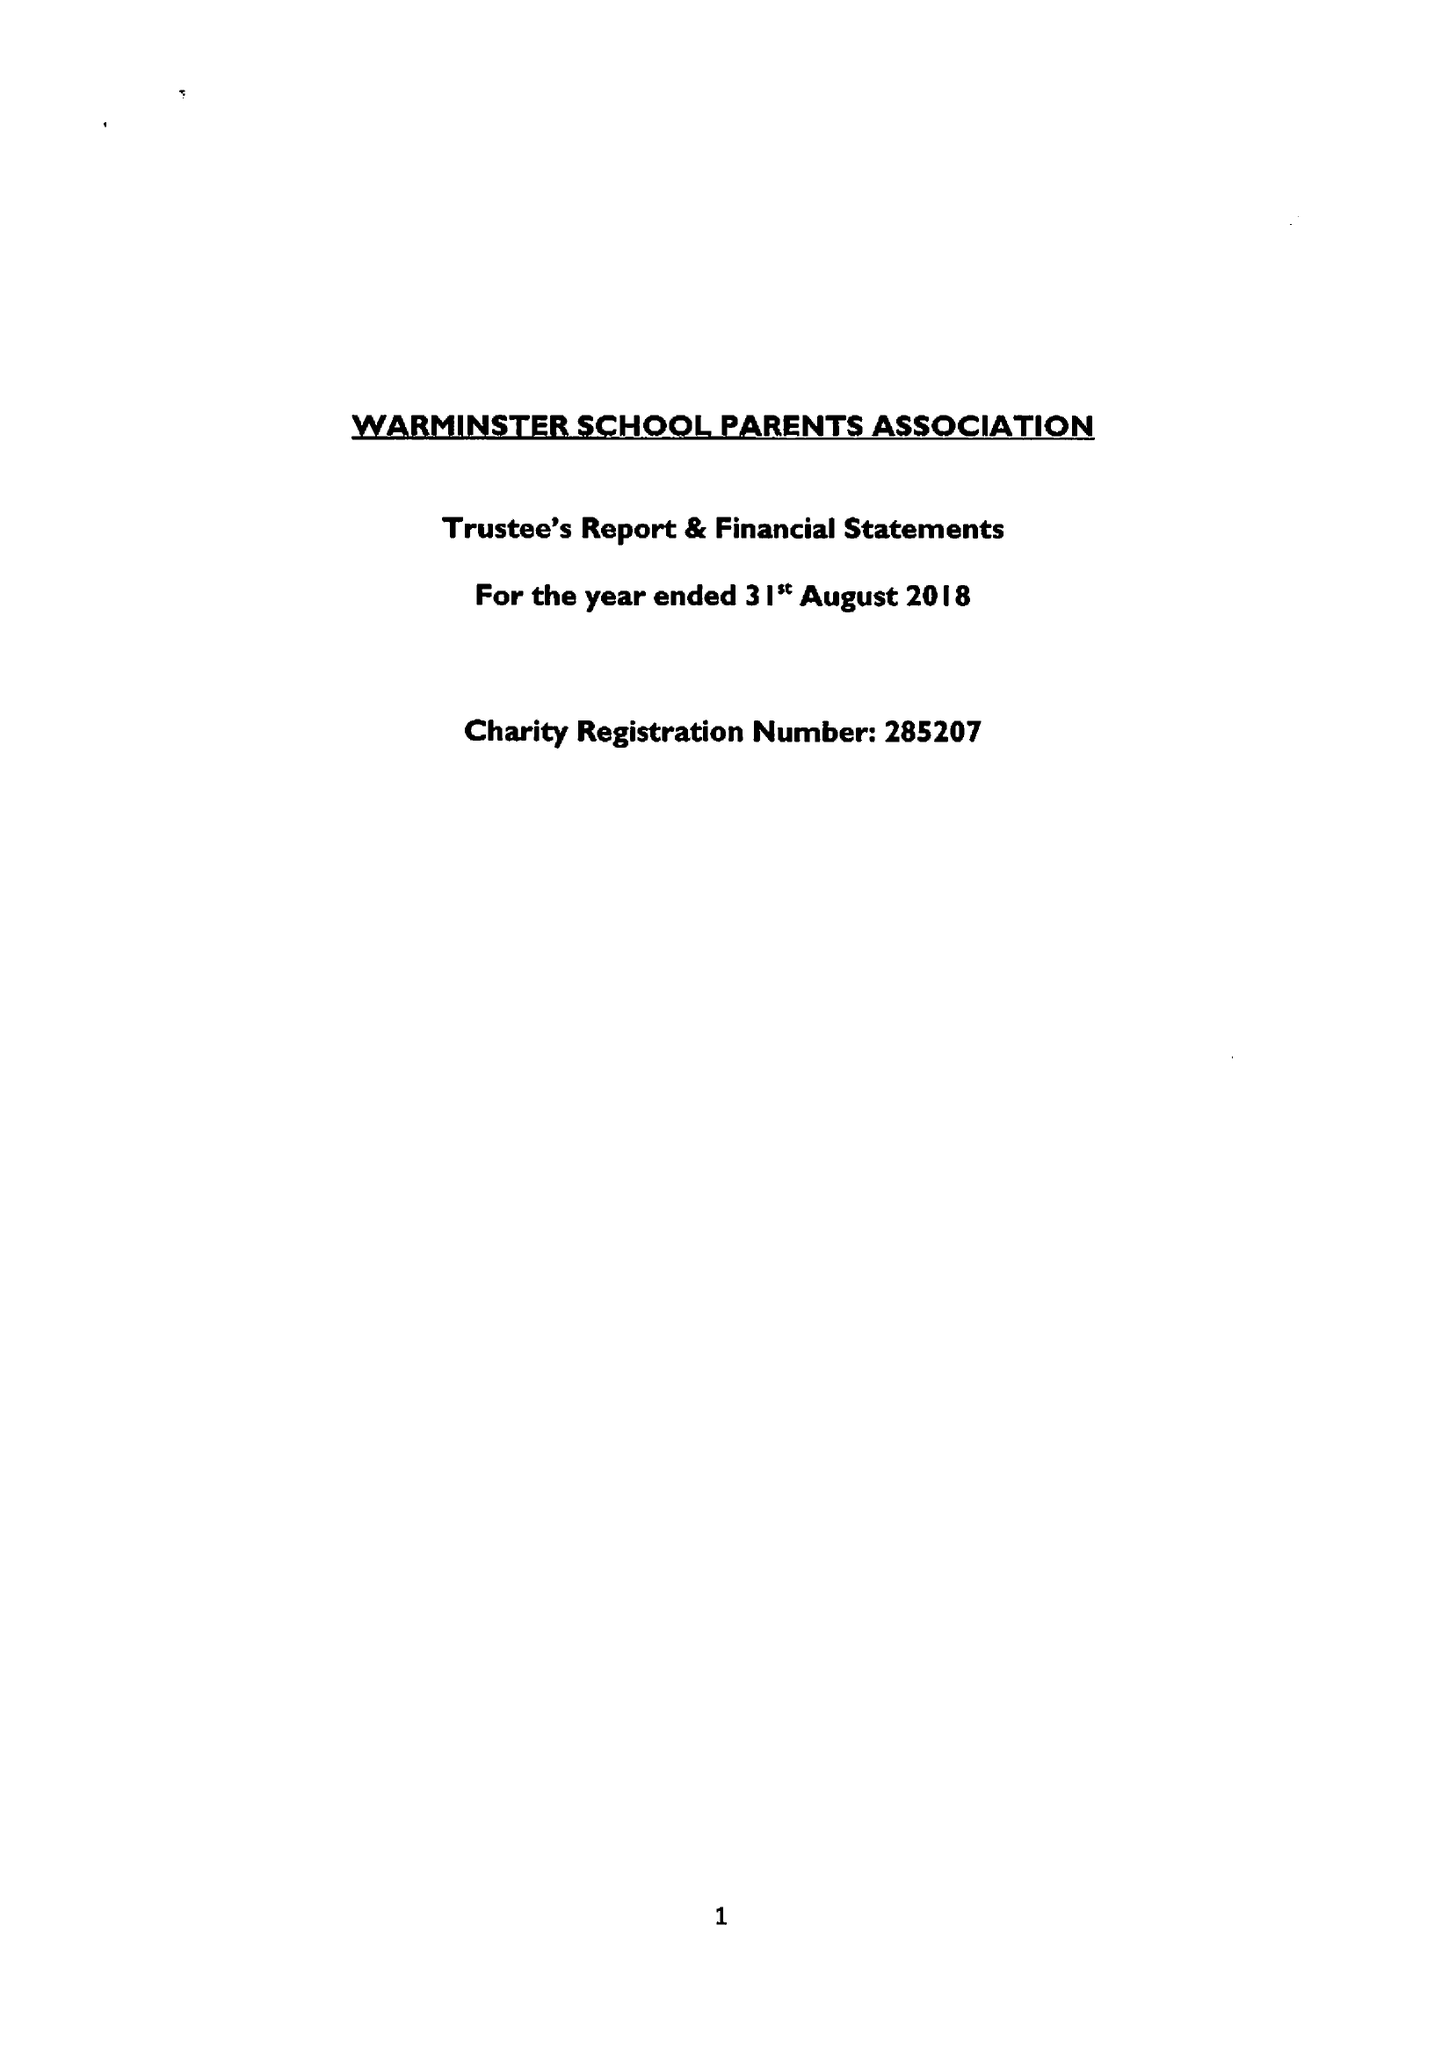What is the value for the address__postcode?
Answer the question using a single word or phrase. BA12 8PJ 